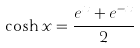<formula> <loc_0><loc_0><loc_500><loc_500>\cosh x = \frac { e ^ { x } + e ^ { - x } } { 2 }</formula> 